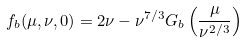Convert formula to latex. <formula><loc_0><loc_0><loc_500><loc_500>f _ { b } ( \mu , \nu , 0 ) = 2 \nu - \nu ^ { 7 / 3 } G _ { b } \left ( \frac { \mu } { \nu ^ { 2 / 3 } } \right )</formula> 